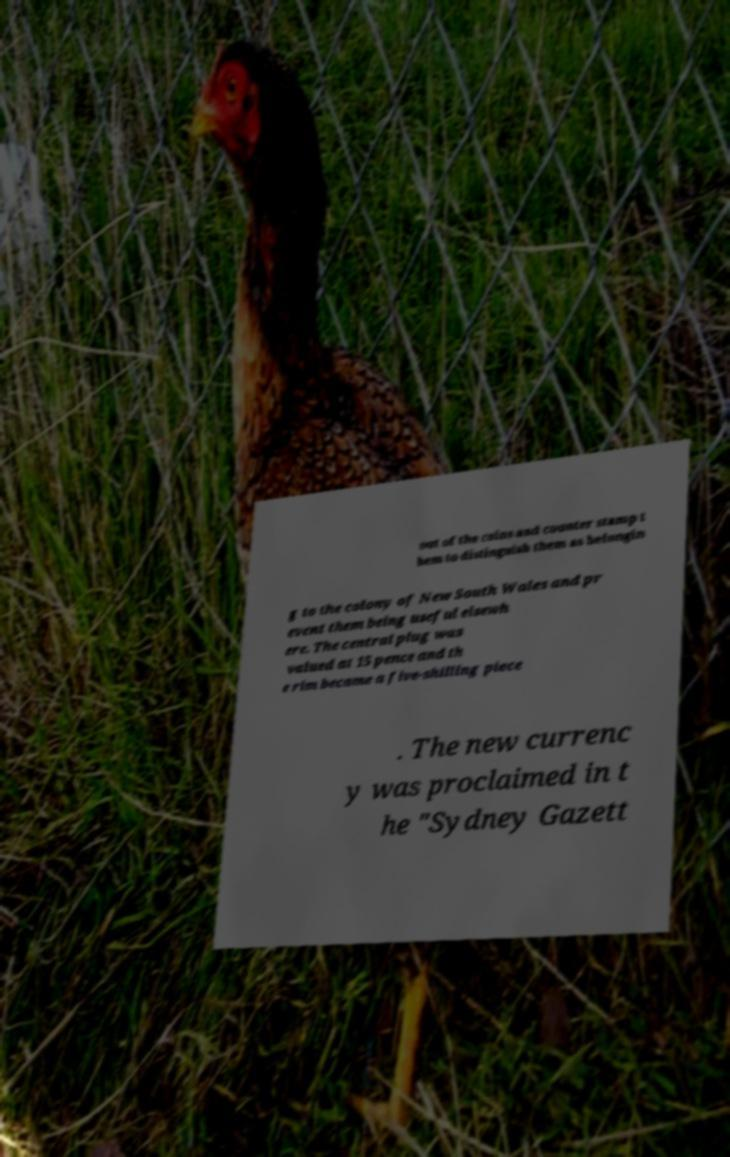I need the written content from this picture converted into text. Can you do that? out of the coins and counter stamp t hem to distinguish them as belongin g to the colony of New South Wales and pr event them being useful elsewh ere. The central plug was valued at 15 pence and th e rim became a five-shilling piece . The new currenc y was proclaimed in t he "Sydney Gazett 